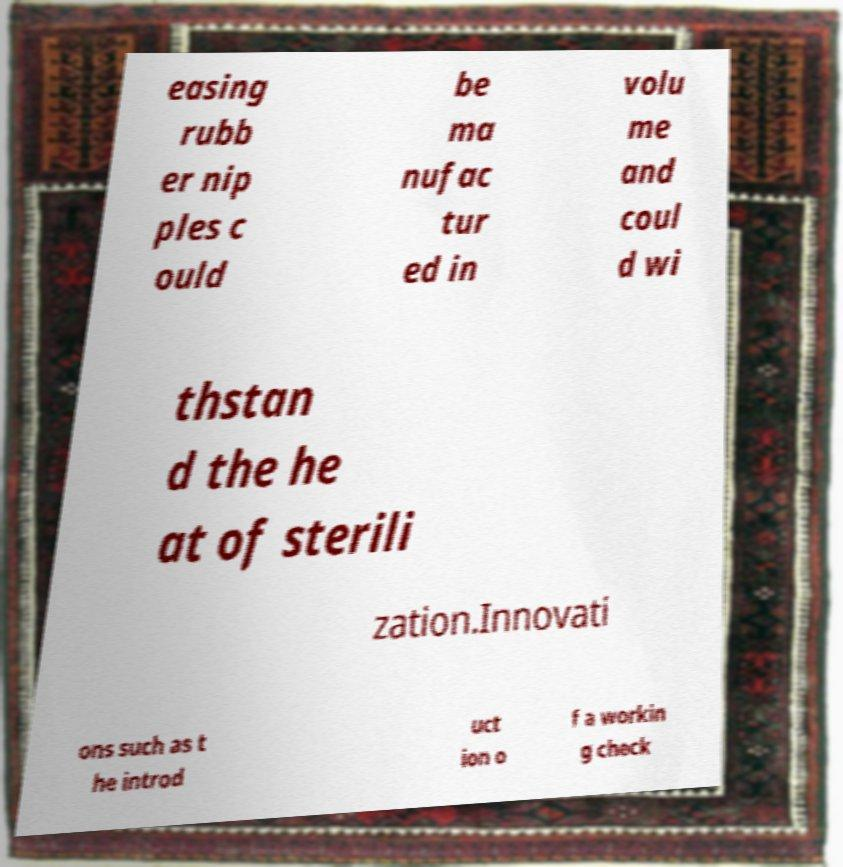Please identify and transcribe the text found in this image. easing rubb er nip ples c ould be ma nufac tur ed in volu me and coul d wi thstan d the he at of sterili zation.Innovati ons such as t he introd uct ion o f a workin g check 